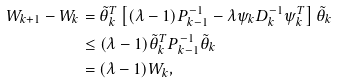<formula> <loc_0><loc_0><loc_500><loc_500>W _ { k + 1 } - W _ { k } & = \tilde { \theta } _ { k } ^ { T } \left [ ( \lambda - 1 ) P _ { k - 1 } ^ { - 1 } - \lambda \psi _ { k } D _ { k } ^ { - 1 } \psi _ { k } ^ { T } \right ] \tilde { \theta } _ { k } \\ & \leq ( \lambda - 1 ) \tilde { \theta } _ { k } ^ { T } P _ { k - 1 } ^ { - 1 } \tilde { \theta } _ { k } \\ & = ( \lambda - 1 ) W _ { k } ,</formula> 